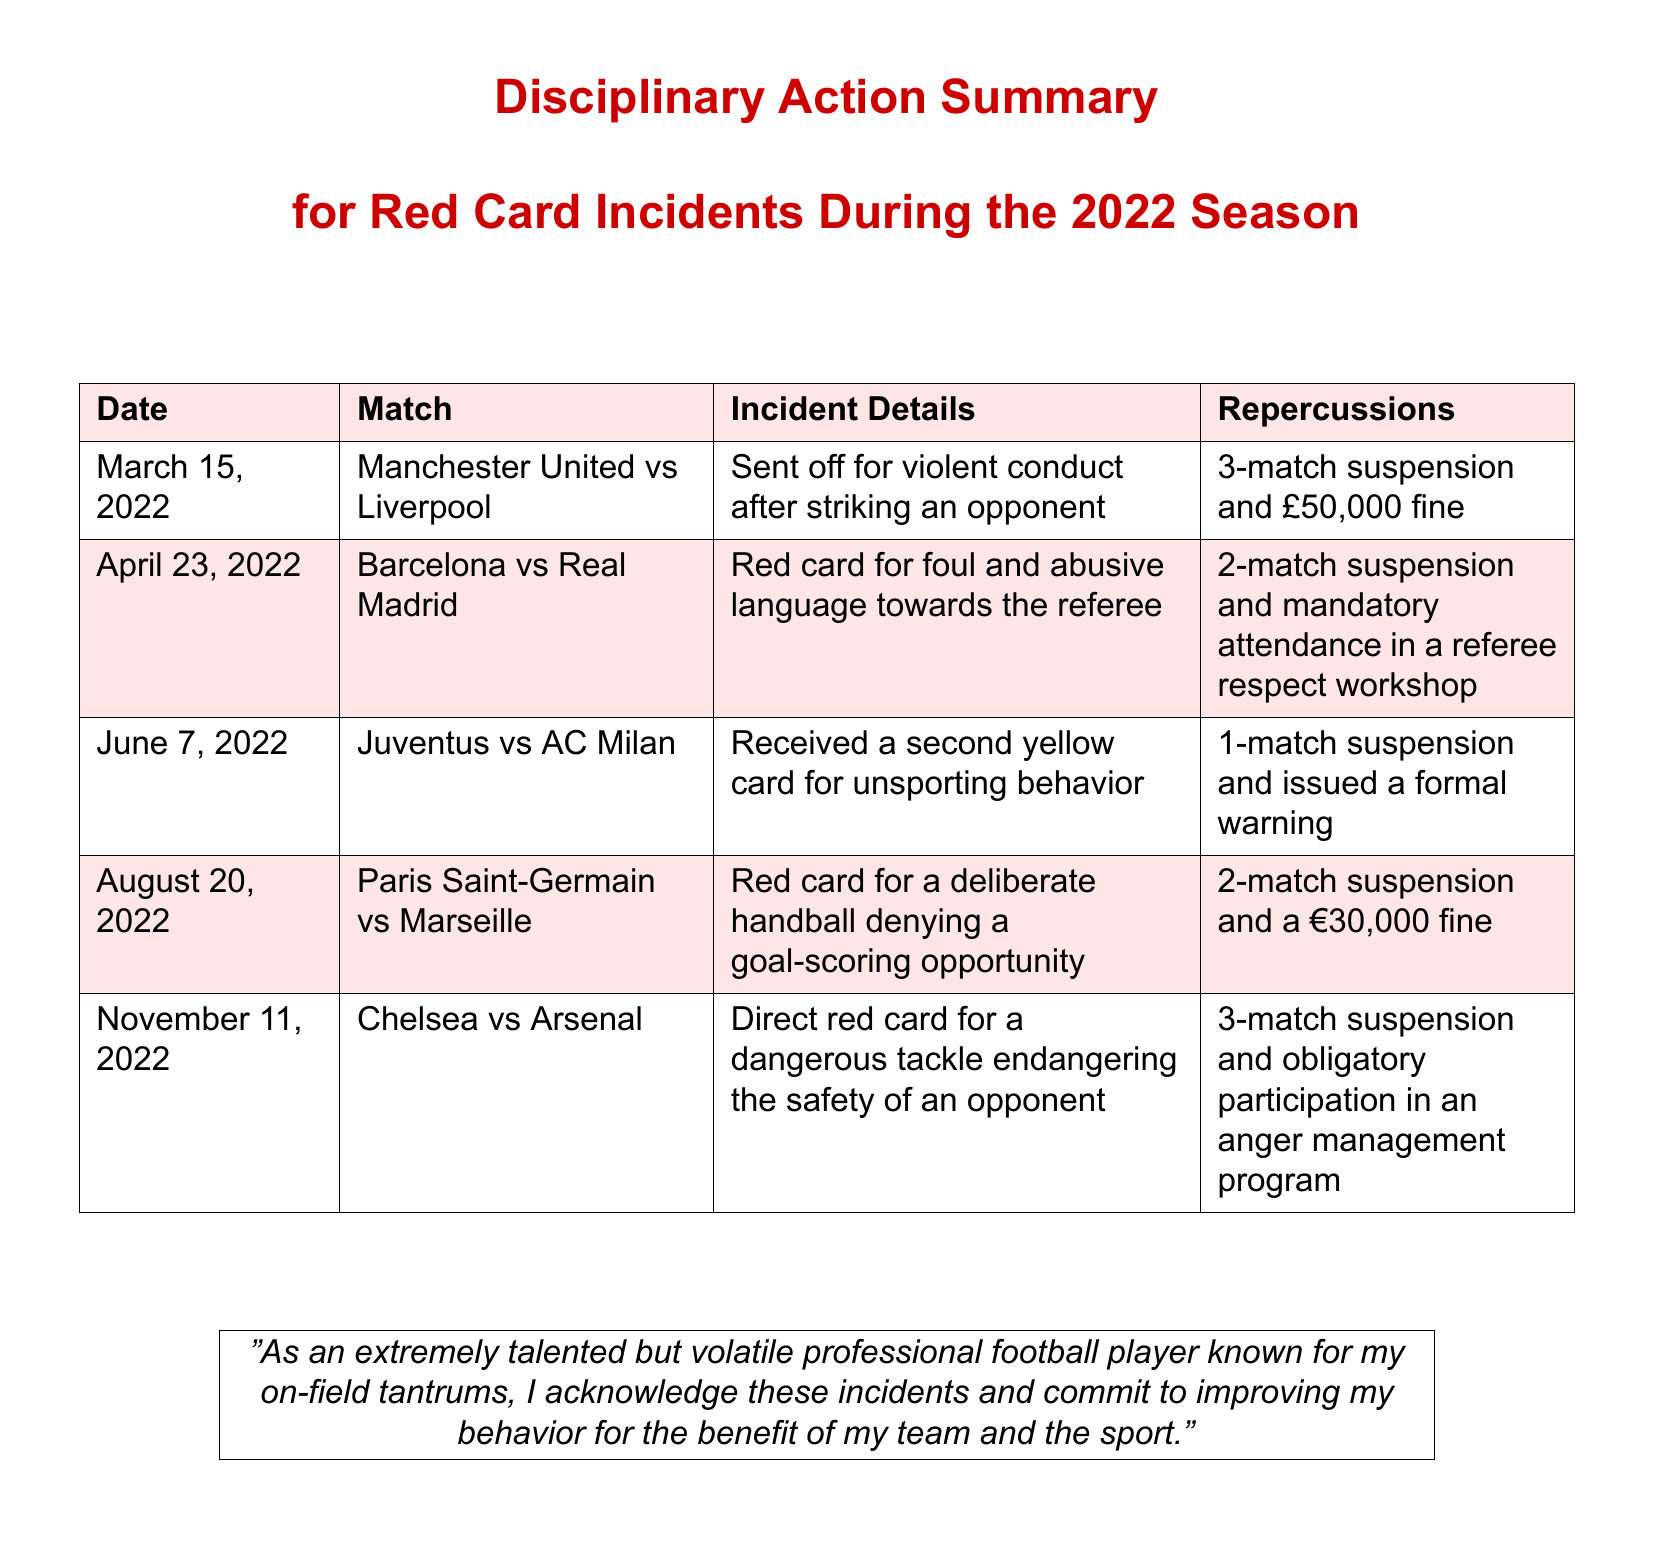What was the incident on March 15, 2022? The incident involved being sent off for violent conduct after striking an opponent.
Answer: Sent off for violent conduct after striking an opponent How many matches was the player suspended for the incident on November 11, 2022? The player received a 3-match suspension for a dangerous tackle.
Answer: 3-match suspension What fine was imposed for the handball incident on August 20, 2022? The fine for the deliberate handball was €30,000.
Answer: €30,000 What workshop was the player required to attend after the incident on April 23, 2022? The player was required to attend a referee respect workshop.
Answer: Referee respect workshop Was there a warning issued after the incident on June 7, 2022? Yes, a formal warning was issued after receiving a second yellow card.
Answer: Yes, formal warning Which match involved a second yellow card? The match with Juventus vs AC Milan saw the second yellow card for unsporting behavior.
Answer: Juventus vs AC Milan What was the repercussion for the incident on April 23, 2022? The repercussions included a 2-match suspension and mandatory attendance in a workshop.
Answer: 2-match suspension and workshop How many incidents were documented? There were five documented incidents of red card events during the 2022 season.
Answer: Five incidents What was the date of the incident involving a dangerous tackle? The date of the incident involving a dangerous tackle was November 11, 2022.
Answer: November 11, 2022 